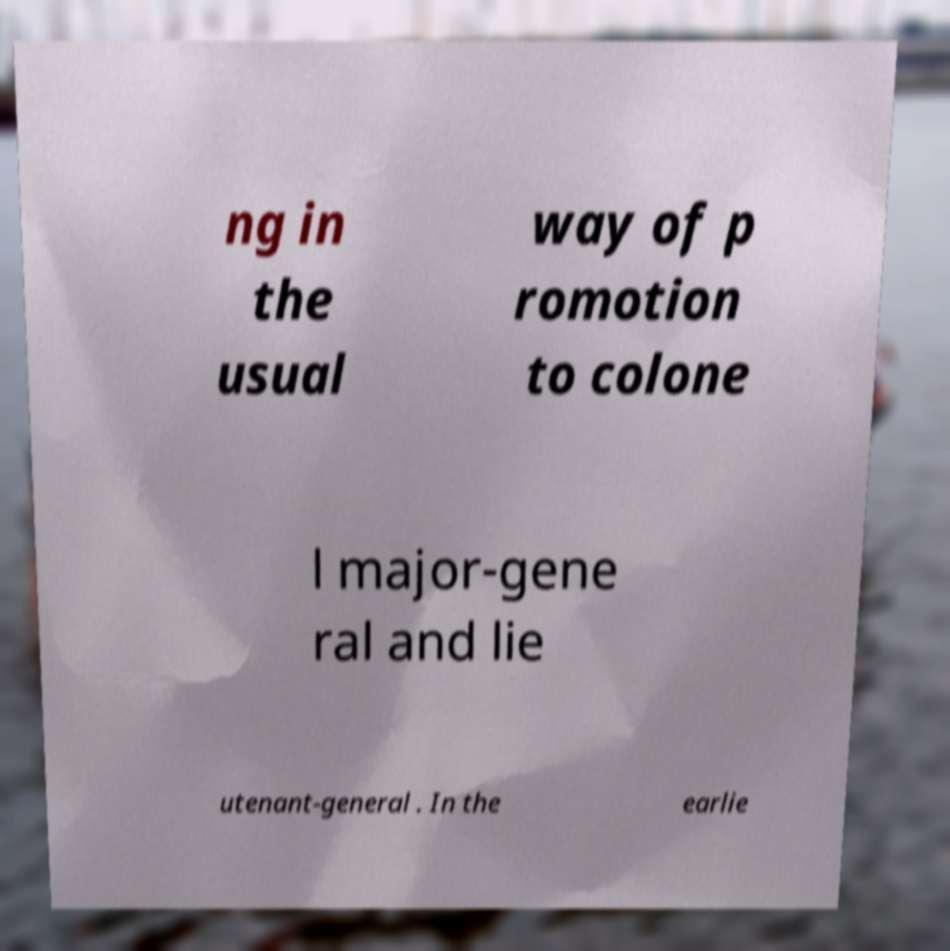I need the written content from this picture converted into text. Can you do that? ng in the usual way of p romotion to colone l major-gene ral and lie utenant-general . In the earlie 